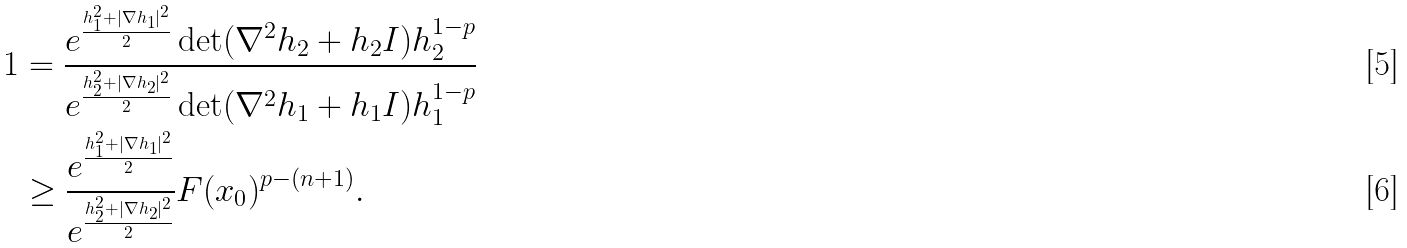Convert formula to latex. <formula><loc_0><loc_0><loc_500><loc_500>1 & = \frac { e ^ { \frac { h ^ { 2 } _ { 1 } + | \nabla h _ { 1 } | ^ { 2 } } { 2 } } \det ( \nabla ^ { 2 } h _ { 2 } + h _ { 2 } I ) h _ { 2 } ^ { 1 - p } } { e ^ { \frac { h _ { 2 } ^ { 2 } + | \nabla h _ { 2 } | ^ { 2 } } { 2 } } \det ( \nabla ^ { 2 } h _ { 1 } + h _ { 1 } I ) h _ { 1 } ^ { 1 - p } } \\ & \geq \frac { e ^ { \frac { h ^ { 2 } _ { 1 } + | \nabla h _ { 1 } | ^ { 2 } } { 2 } } } { e ^ { \frac { h _ { 2 } ^ { 2 } + | \nabla h _ { 2 } | ^ { 2 } } { 2 } } } F ( x _ { 0 } ) ^ { p - ( n + 1 ) } .</formula> 